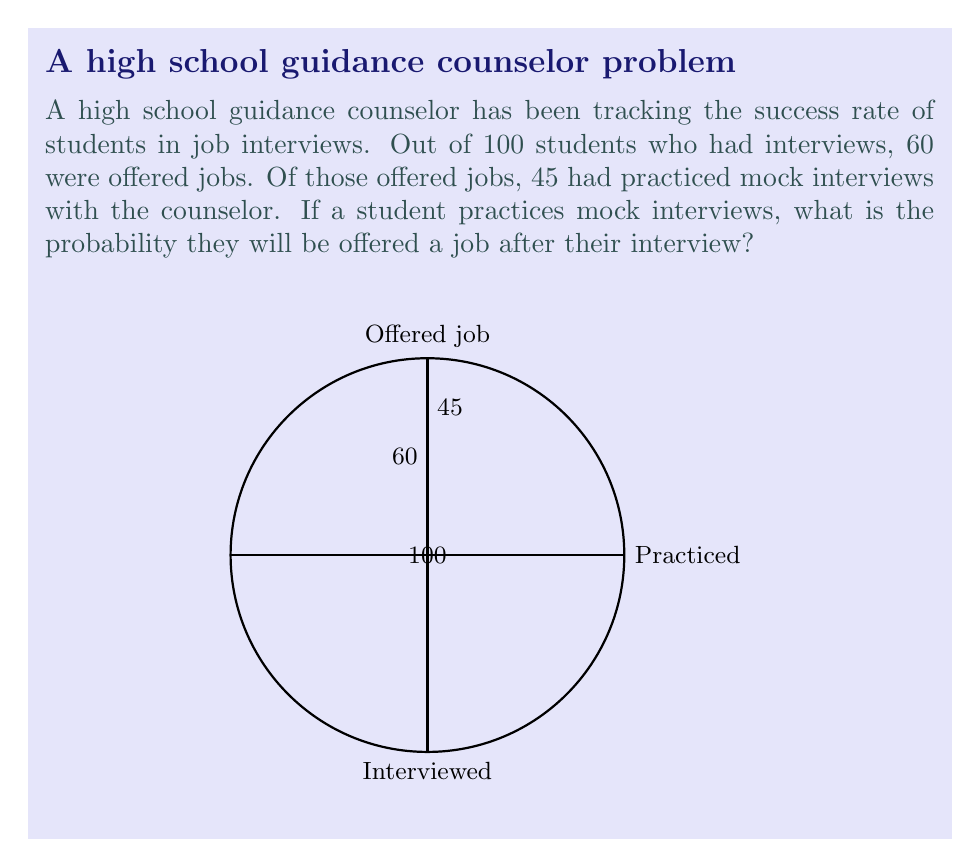Give your solution to this math problem. Let's approach this step-by-step using conditional probability:

1) Let's define our events:
   A: Student is offered a job
   B: Student practiced mock interviews

2) We're looking for P(A|B), the probability of being offered a job given that the student practiced mock interviews.

3) We can use Bayes' theorem:

   $$P(A|B) = \frac{P(B|A) \cdot P(A)}{P(B)}$$

4) From the given information:
   - P(A) = 60/100 = 0.6 (probability of being offered a job)
   - P(B|A) = 45/60 = 0.75 (probability of having practiced, given that they were offered a job)

5) We don't know P(B) directly, but we can assume that students who weren't offered jobs also practiced. Let's say x students who weren't offered jobs practiced. Then:

   P(B) = (45 + x) / 100

6) Substituting into Bayes' theorem:

   $$\frac{0.75 \cdot 0.6}{(45 + x) / 100} = \frac{45}{45 + x}$$

7) This is true for any value of x. The question doesn't provide enough information to determine x, but we can conclude that P(A|B) = 45/(45 + x), which is always greater than or equal to 45/100 = 0.45.

8) Therefore, the probability of being offered a job after practicing mock interviews is at least 0.45 or 45%.
Answer: $\geq 0.45$ or $\geq 45\%$ 